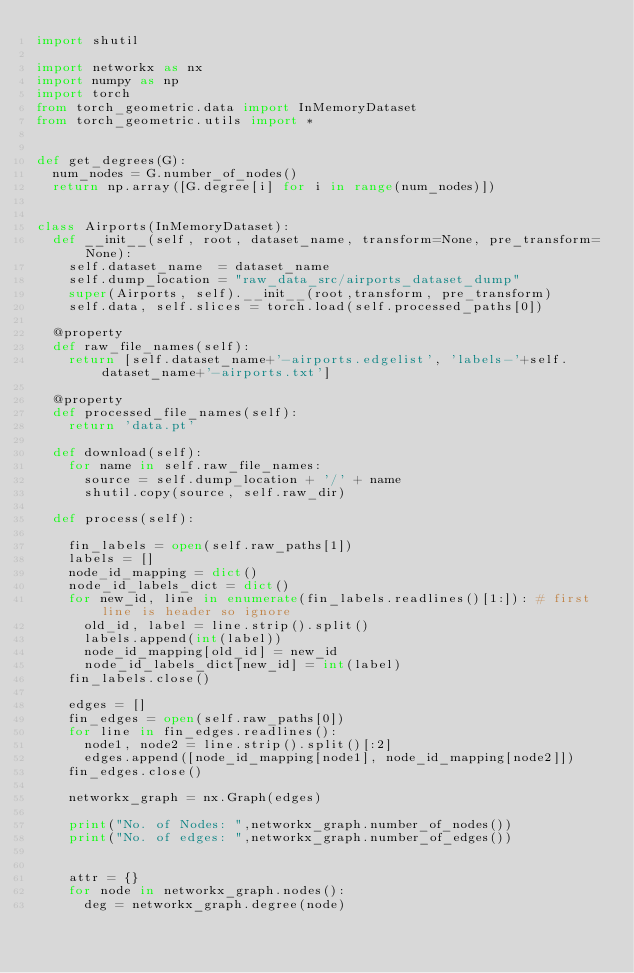Convert code to text. <code><loc_0><loc_0><loc_500><loc_500><_Python_>import shutil

import networkx as nx
import numpy as np
import torch
from torch_geometric.data import InMemoryDataset
from torch_geometric.utils import *


def get_degrees(G):
	num_nodes = G.number_of_nodes()
	return np.array([G.degree[i] for i in range(num_nodes)])


class Airports(InMemoryDataset):
	def __init__(self, root, dataset_name, transform=None, pre_transform=None):
		self.dataset_name  = dataset_name
		self.dump_location = "raw_data_src/airports_dataset_dump"
		super(Airports, self).__init__(root,transform, pre_transform)
		self.data, self.slices = torch.load(self.processed_paths[0])

	@property
	def raw_file_names(self):
		return [self.dataset_name+'-airports.edgelist', 'labels-'+self.dataset_name+'-airports.txt']

	@property
	def processed_file_names(self):
		return 'data.pt'

	def download(self):
		for name in self.raw_file_names:
			source = self.dump_location + '/' + name
			shutil.copy(source, self.raw_dir)

	def process(self):

		fin_labels = open(self.raw_paths[1])
		labels = []
		node_id_mapping = dict()
		node_id_labels_dict = dict()
		for new_id, line in enumerate(fin_labels.readlines()[1:]): # first line is header so ignore
			old_id, label = line.strip().split()
			labels.append(int(label))
			node_id_mapping[old_id] = new_id
			node_id_labels_dict[new_id] = int(label)
		fin_labels.close()

		edges = []
		fin_edges = open(self.raw_paths[0])
		for line in fin_edges.readlines():
			node1, node2 = line.strip().split()[:2]
			edges.append([node_id_mapping[node1], node_id_mapping[node2]])
		fin_edges.close()

		networkx_graph = nx.Graph(edges)

		print("No. of Nodes: ",networkx_graph.number_of_nodes())
		print("No. of edges: ",networkx_graph.number_of_edges())


		attr = {}
		for node in networkx_graph.nodes():
			deg = networkx_graph.degree(node)</code> 